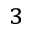<formula> <loc_0><loc_0><loc_500><loc_500>^ { 3 }</formula> 